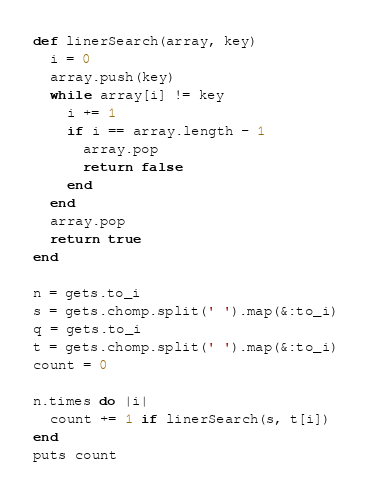<code> <loc_0><loc_0><loc_500><loc_500><_Ruby_>def linerSearch(array, key)
  i = 0
  array.push(key)
  while array[i] != key
    i += 1
    if i == array.length - 1
      array.pop
      return false
    end
  end
  array.pop
  return true
end

n = gets.to_i
s = gets.chomp.split(' ').map(&:to_i)
q = gets.to_i
t = gets.chomp.split(' ').map(&:to_i)
count = 0

n.times do |i|
  count += 1 if linerSearch(s, t[i])
end
puts count</code> 